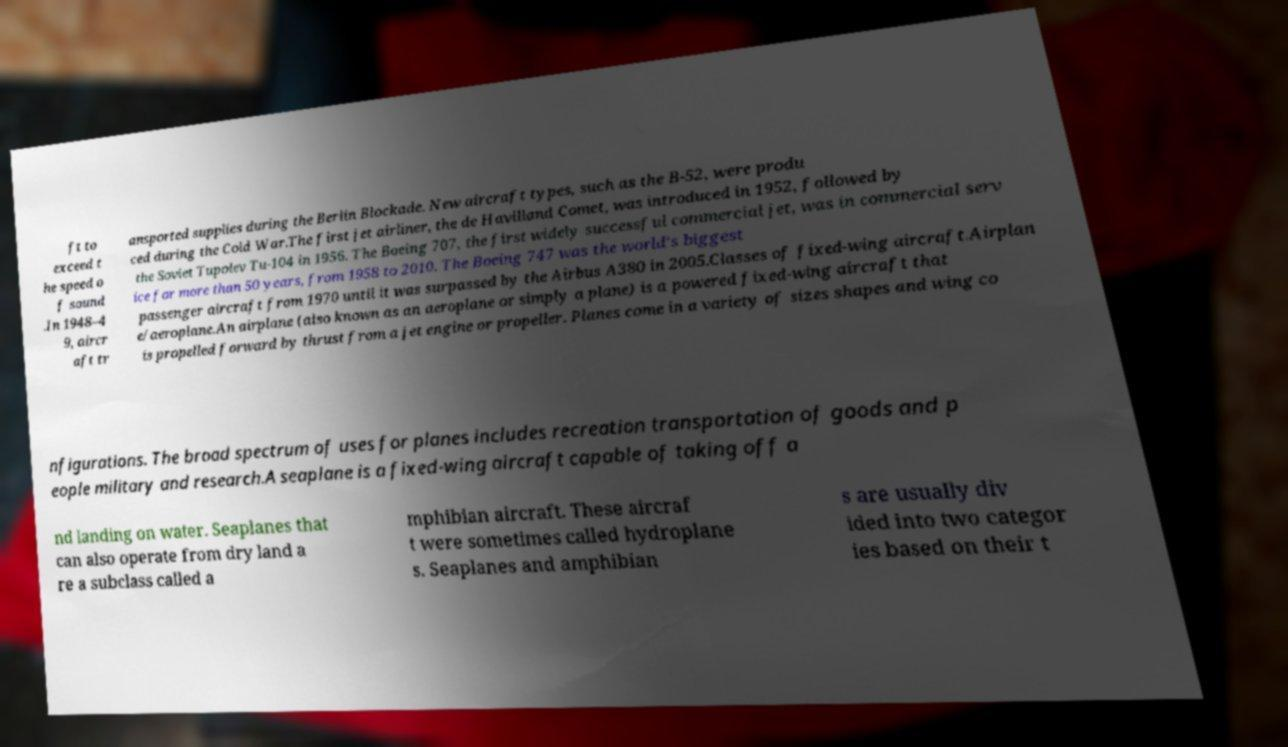Can you read and provide the text displayed in the image?This photo seems to have some interesting text. Can you extract and type it out for me? ft to exceed t he speed o f sound .In 1948–4 9, aircr aft tr ansported supplies during the Berlin Blockade. New aircraft types, such as the B-52, were produ ced during the Cold War.The first jet airliner, the de Havilland Comet, was introduced in 1952, followed by the Soviet Tupolev Tu-104 in 1956. The Boeing 707, the first widely successful commercial jet, was in commercial serv ice for more than 50 years, from 1958 to 2010. The Boeing 747 was the world's biggest passenger aircraft from 1970 until it was surpassed by the Airbus A380 in 2005.Classes of fixed-wing aircraft.Airplan e/aeroplane.An airplane (also known as an aeroplane or simply a plane) is a powered fixed-wing aircraft that is propelled forward by thrust from a jet engine or propeller. Planes come in a variety of sizes shapes and wing co nfigurations. The broad spectrum of uses for planes includes recreation transportation of goods and p eople military and research.A seaplane is a fixed-wing aircraft capable of taking off a nd landing on water. Seaplanes that can also operate from dry land a re a subclass called a mphibian aircraft. These aircraf t were sometimes called hydroplane s. Seaplanes and amphibian s are usually div ided into two categor ies based on their t 